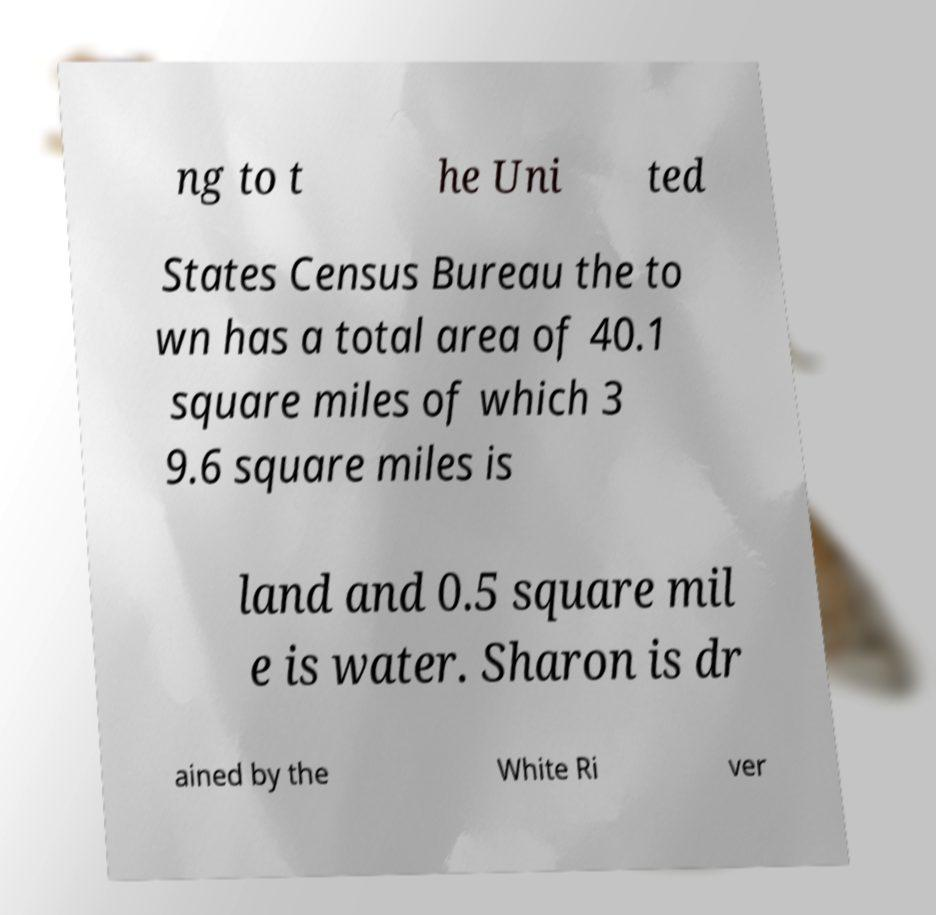Can you accurately transcribe the text from the provided image for me? ng to t he Uni ted States Census Bureau the to wn has a total area of 40.1 square miles of which 3 9.6 square miles is land and 0.5 square mil e is water. Sharon is dr ained by the White Ri ver 